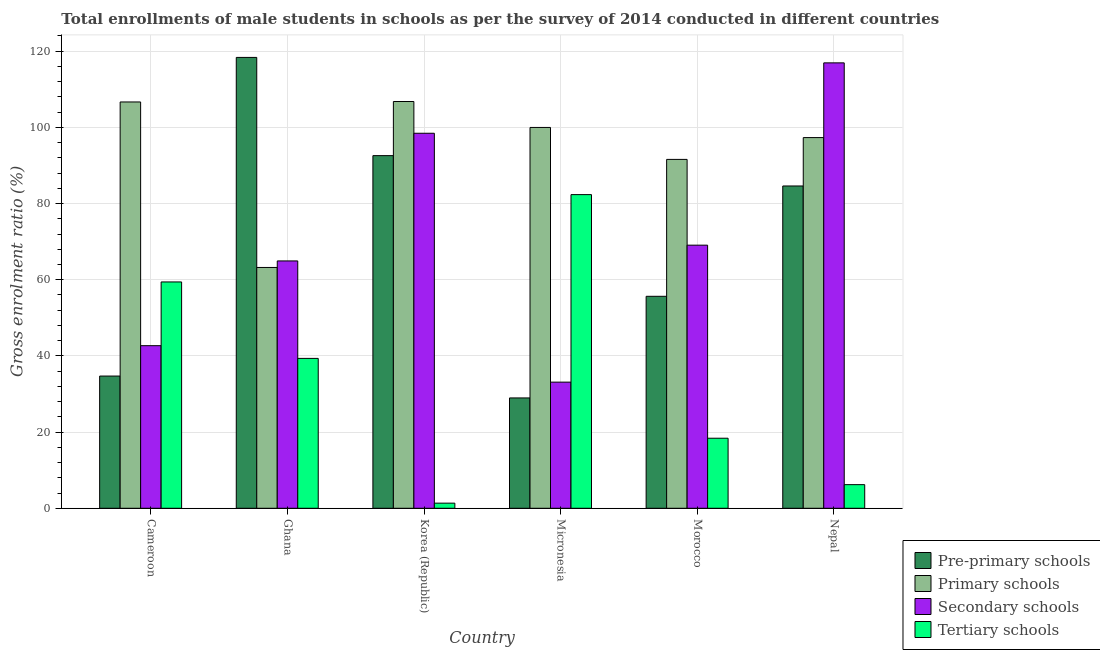How many different coloured bars are there?
Provide a short and direct response. 4. How many groups of bars are there?
Your answer should be compact. 6. How many bars are there on the 4th tick from the left?
Provide a short and direct response. 4. What is the label of the 5th group of bars from the left?
Keep it short and to the point. Morocco. What is the gross enrolment ratio(male) in secondary schools in Korea (Republic)?
Offer a terse response. 98.45. Across all countries, what is the maximum gross enrolment ratio(male) in tertiary schools?
Provide a succinct answer. 82.35. Across all countries, what is the minimum gross enrolment ratio(male) in secondary schools?
Your response must be concise. 33.12. In which country was the gross enrolment ratio(male) in secondary schools maximum?
Ensure brevity in your answer.  Nepal. What is the total gross enrolment ratio(male) in tertiary schools in the graph?
Offer a terse response. 207.05. What is the difference between the gross enrolment ratio(male) in secondary schools in Ghana and that in Morocco?
Provide a succinct answer. -4.14. What is the difference between the gross enrolment ratio(male) in primary schools in Korea (Republic) and the gross enrolment ratio(male) in pre-primary schools in Morocco?
Give a very brief answer. 51.14. What is the average gross enrolment ratio(male) in pre-primary schools per country?
Provide a succinct answer. 69.15. What is the difference between the gross enrolment ratio(male) in secondary schools and gross enrolment ratio(male) in tertiary schools in Korea (Republic)?
Offer a very short reply. 97.11. In how many countries, is the gross enrolment ratio(male) in tertiary schools greater than 24 %?
Give a very brief answer. 3. What is the ratio of the gross enrolment ratio(male) in pre-primary schools in Korea (Republic) to that in Nepal?
Your answer should be compact. 1.09. Is the gross enrolment ratio(male) in pre-primary schools in Ghana less than that in Morocco?
Make the answer very short. No. Is the difference between the gross enrolment ratio(male) in tertiary schools in Cameroon and Morocco greater than the difference between the gross enrolment ratio(male) in pre-primary schools in Cameroon and Morocco?
Offer a very short reply. Yes. What is the difference between the highest and the second highest gross enrolment ratio(male) in pre-primary schools?
Keep it short and to the point. 25.78. What is the difference between the highest and the lowest gross enrolment ratio(male) in secondary schools?
Offer a terse response. 83.82. Is the sum of the gross enrolment ratio(male) in pre-primary schools in Korea (Republic) and Nepal greater than the maximum gross enrolment ratio(male) in tertiary schools across all countries?
Give a very brief answer. Yes. What does the 3rd bar from the left in Morocco represents?
Keep it short and to the point. Secondary schools. What does the 4th bar from the right in Nepal represents?
Provide a succinct answer. Pre-primary schools. Are all the bars in the graph horizontal?
Your response must be concise. No. Are the values on the major ticks of Y-axis written in scientific E-notation?
Give a very brief answer. No. Does the graph contain any zero values?
Offer a terse response. No. How many legend labels are there?
Ensure brevity in your answer.  4. What is the title of the graph?
Your response must be concise. Total enrollments of male students in schools as per the survey of 2014 conducted in different countries. What is the label or title of the X-axis?
Your response must be concise. Country. What is the label or title of the Y-axis?
Keep it short and to the point. Gross enrolment ratio (%). What is the Gross enrolment ratio (%) in Pre-primary schools in Cameroon?
Give a very brief answer. 34.71. What is the Gross enrolment ratio (%) of Primary schools in Cameroon?
Make the answer very short. 106.67. What is the Gross enrolment ratio (%) of Secondary schools in Cameroon?
Provide a short and direct response. 42.69. What is the Gross enrolment ratio (%) in Tertiary schools in Cameroon?
Offer a terse response. 59.42. What is the Gross enrolment ratio (%) of Pre-primary schools in Ghana?
Offer a very short reply. 118.37. What is the Gross enrolment ratio (%) of Primary schools in Ghana?
Your answer should be very brief. 63.22. What is the Gross enrolment ratio (%) in Secondary schools in Ghana?
Your answer should be compact. 64.94. What is the Gross enrolment ratio (%) of Tertiary schools in Ghana?
Provide a succinct answer. 39.35. What is the Gross enrolment ratio (%) of Pre-primary schools in Korea (Republic)?
Your response must be concise. 92.58. What is the Gross enrolment ratio (%) of Primary schools in Korea (Republic)?
Provide a short and direct response. 106.79. What is the Gross enrolment ratio (%) of Secondary schools in Korea (Republic)?
Keep it short and to the point. 98.45. What is the Gross enrolment ratio (%) in Tertiary schools in Korea (Republic)?
Your response must be concise. 1.35. What is the Gross enrolment ratio (%) of Pre-primary schools in Micronesia?
Make the answer very short. 28.97. What is the Gross enrolment ratio (%) in Primary schools in Micronesia?
Ensure brevity in your answer.  99.98. What is the Gross enrolment ratio (%) in Secondary schools in Micronesia?
Give a very brief answer. 33.12. What is the Gross enrolment ratio (%) in Tertiary schools in Micronesia?
Offer a terse response. 82.35. What is the Gross enrolment ratio (%) of Pre-primary schools in Morocco?
Provide a short and direct response. 55.65. What is the Gross enrolment ratio (%) of Primary schools in Morocco?
Your response must be concise. 91.59. What is the Gross enrolment ratio (%) in Secondary schools in Morocco?
Offer a very short reply. 69.08. What is the Gross enrolment ratio (%) of Tertiary schools in Morocco?
Offer a very short reply. 18.39. What is the Gross enrolment ratio (%) in Pre-primary schools in Nepal?
Your response must be concise. 84.62. What is the Gross enrolment ratio (%) in Primary schools in Nepal?
Provide a succinct answer. 97.32. What is the Gross enrolment ratio (%) of Secondary schools in Nepal?
Your response must be concise. 116.94. What is the Gross enrolment ratio (%) in Tertiary schools in Nepal?
Offer a very short reply. 6.2. Across all countries, what is the maximum Gross enrolment ratio (%) in Pre-primary schools?
Offer a very short reply. 118.37. Across all countries, what is the maximum Gross enrolment ratio (%) of Primary schools?
Your answer should be compact. 106.79. Across all countries, what is the maximum Gross enrolment ratio (%) in Secondary schools?
Make the answer very short. 116.94. Across all countries, what is the maximum Gross enrolment ratio (%) in Tertiary schools?
Provide a short and direct response. 82.35. Across all countries, what is the minimum Gross enrolment ratio (%) in Pre-primary schools?
Your response must be concise. 28.97. Across all countries, what is the minimum Gross enrolment ratio (%) of Primary schools?
Give a very brief answer. 63.22. Across all countries, what is the minimum Gross enrolment ratio (%) in Secondary schools?
Provide a succinct answer. 33.12. Across all countries, what is the minimum Gross enrolment ratio (%) of Tertiary schools?
Give a very brief answer. 1.35. What is the total Gross enrolment ratio (%) of Pre-primary schools in the graph?
Provide a succinct answer. 414.89. What is the total Gross enrolment ratio (%) in Primary schools in the graph?
Your answer should be very brief. 565.57. What is the total Gross enrolment ratio (%) of Secondary schools in the graph?
Keep it short and to the point. 425.21. What is the total Gross enrolment ratio (%) of Tertiary schools in the graph?
Give a very brief answer. 207.05. What is the difference between the Gross enrolment ratio (%) in Pre-primary schools in Cameroon and that in Ghana?
Your response must be concise. -83.65. What is the difference between the Gross enrolment ratio (%) in Primary schools in Cameroon and that in Ghana?
Your response must be concise. 43.45. What is the difference between the Gross enrolment ratio (%) of Secondary schools in Cameroon and that in Ghana?
Offer a terse response. -22.25. What is the difference between the Gross enrolment ratio (%) in Tertiary schools in Cameroon and that in Ghana?
Ensure brevity in your answer.  20.07. What is the difference between the Gross enrolment ratio (%) in Pre-primary schools in Cameroon and that in Korea (Republic)?
Give a very brief answer. -57.87. What is the difference between the Gross enrolment ratio (%) of Primary schools in Cameroon and that in Korea (Republic)?
Offer a terse response. -0.12. What is the difference between the Gross enrolment ratio (%) of Secondary schools in Cameroon and that in Korea (Republic)?
Offer a terse response. -55.77. What is the difference between the Gross enrolment ratio (%) in Tertiary schools in Cameroon and that in Korea (Republic)?
Ensure brevity in your answer.  58.07. What is the difference between the Gross enrolment ratio (%) of Pre-primary schools in Cameroon and that in Micronesia?
Your answer should be compact. 5.74. What is the difference between the Gross enrolment ratio (%) of Primary schools in Cameroon and that in Micronesia?
Your response must be concise. 6.69. What is the difference between the Gross enrolment ratio (%) in Secondary schools in Cameroon and that in Micronesia?
Provide a succinct answer. 9.57. What is the difference between the Gross enrolment ratio (%) in Tertiary schools in Cameroon and that in Micronesia?
Keep it short and to the point. -22.93. What is the difference between the Gross enrolment ratio (%) in Pre-primary schools in Cameroon and that in Morocco?
Give a very brief answer. -20.94. What is the difference between the Gross enrolment ratio (%) of Primary schools in Cameroon and that in Morocco?
Give a very brief answer. 15.08. What is the difference between the Gross enrolment ratio (%) of Secondary schools in Cameroon and that in Morocco?
Keep it short and to the point. -26.39. What is the difference between the Gross enrolment ratio (%) of Tertiary schools in Cameroon and that in Morocco?
Provide a short and direct response. 41.03. What is the difference between the Gross enrolment ratio (%) in Pre-primary schools in Cameroon and that in Nepal?
Provide a short and direct response. -49.9. What is the difference between the Gross enrolment ratio (%) in Primary schools in Cameroon and that in Nepal?
Ensure brevity in your answer.  9.35. What is the difference between the Gross enrolment ratio (%) in Secondary schools in Cameroon and that in Nepal?
Provide a succinct answer. -74.25. What is the difference between the Gross enrolment ratio (%) of Tertiary schools in Cameroon and that in Nepal?
Ensure brevity in your answer.  53.21. What is the difference between the Gross enrolment ratio (%) in Pre-primary schools in Ghana and that in Korea (Republic)?
Give a very brief answer. 25.78. What is the difference between the Gross enrolment ratio (%) in Primary schools in Ghana and that in Korea (Republic)?
Offer a terse response. -43.57. What is the difference between the Gross enrolment ratio (%) of Secondary schools in Ghana and that in Korea (Republic)?
Provide a short and direct response. -33.52. What is the difference between the Gross enrolment ratio (%) of Tertiary schools in Ghana and that in Korea (Republic)?
Provide a succinct answer. 38. What is the difference between the Gross enrolment ratio (%) of Pre-primary schools in Ghana and that in Micronesia?
Offer a terse response. 89.4. What is the difference between the Gross enrolment ratio (%) in Primary schools in Ghana and that in Micronesia?
Provide a succinct answer. -36.76. What is the difference between the Gross enrolment ratio (%) of Secondary schools in Ghana and that in Micronesia?
Ensure brevity in your answer.  31.82. What is the difference between the Gross enrolment ratio (%) in Tertiary schools in Ghana and that in Micronesia?
Offer a very short reply. -43. What is the difference between the Gross enrolment ratio (%) in Pre-primary schools in Ghana and that in Morocco?
Keep it short and to the point. 62.72. What is the difference between the Gross enrolment ratio (%) in Primary schools in Ghana and that in Morocco?
Offer a terse response. -28.37. What is the difference between the Gross enrolment ratio (%) in Secondary schools in Ghana and that in Morocco?
Provide a short and direct response. -4.14. What is the difference between the Gross enrolment ratio (%) of Tertiary schools in Ghana and that in Morocco?
Your answer should be very brief. 20.96. What is the difference between the Gross enrolment ratio (%) of Pre-primary schools in Ghana and that in Nepal?
Make the answer very short. 33.75. What is the difference between the Gross enrolment ratio (%) of Primary schools in Ghana and that in Nepal?
Ensure brevity in your answer.  -34.1. What is the difference between the Gross enrolment ratio (%) in Secondary schools in Ghana and that in Nepal?
Make the answer very short. -52. What is the difference between the Gross enrolment ratio (%) of Tertiary schools in Ghana and that in Nepal?
Provide a succinct answer. 33.14. What is the difference between the Gross enrolment ratio (%) of Pre-primary schools in Korea (Republic) and that in Micronesia?
Provide a succinct answer. 63.61. What is the difference between the Gross enrolment ratio (%) in Primary schools in Korea (Republic) and that in Micronesia?
Provide a succinct answer. 6.81. What is the difference between the Gross enrolment ratio (%) in Secondary schools in Korea (Republic) and that in Micronesia?
Ensure brevity in your answer.  65.34. What is the difference between the Gross enrolment ratio (%) of Tertiary schools in Korea (Republic) and that in Micronesia?
Your response must be concise. -81. What is the difference between the Gross enrolment ratio (%) of Pre-primary schools in Korea (Republic) and that in Morocco?
Make the answer very short. 36.93. What is the difference between the Gross enrolment ratio (%) in Primary schools in Korea (Republic) and that in Morocco?
Your answer should be very brief. 15.2. What is the difference between the Gross enrolment ratio (%) of Secondary schools in Korea (Republic) and that in Morocco?
Provide a succinct answer. 29.38. What is the difference between the Gross enrolment ratio (%) of Tertiary schools in Korea (Republic) and that in Morocco?
Your answer should be compact. -17.04. What is the difference between the Gross enrolment ratio (%) in Pre-primary schools in Korea (Republic) and that in Nepal?
Offer a very short reply. 7.97. What is the difference between the Gross enrolment ratio (%) in Primary schools in Korea (Republic) and that in Nepal?
Your answer should be very brief. 9.47. What is the difference between the Gross enrolment ratio (%) in Secondary schools in Korea (Republic) and that in Nepal?
Provide a succinct answer. -18.48. What is the difference between the Gross enrolment ratio (%) in Tertiary schools in Korea (Republic) and that in Nepal?
Ensure brevity in your answer.  -4.86. What is the difference between the Gross enrolment ratio (%) in Pre-primary schools in Micronesia and that in Morocco?
Your answer should be very brief. -26.68. What is the difference between the Gross enrolment ratio (%) in Primary schools in Micronesia and that in Morocco?
Make the answer very short. 8.39. What is the difference between the Gross enrolment ratio (%) of Secondary schools in Micronesia and that in Morocco?
Offer a terse response. -35.96. What is the difference between the Gross enrolment ratio (%) of Tertiary schools in Micronesia and that in Morocco?
Ensure brevity in your answer.  63.96. What is the difference between the Gross enrolment ratio (%) in Pre-primary schools in Micronesia and that in Nepal?
Provide a succinct answer. -55.65. What is the difference between the Gross enrolment ratio (%) of Primary schools in Micronesia and that in Nepal?
Offer a terse response. 2.66. What is the difference between the Gross enrolment ratio (%) of Secondary schools in Micronesia and that in Nepal?
Provide a short and direct response. -83.82. What is the difference between the Gross enrolment ratio (%) of Tertiary schools in Micronesia and that in Nepal?
Ensure brevity in your answer.  76.14. What is the difference between the Gross enrolment ratio (%) in Pre-primary schools in Morocco and that in Nepal?
Offer a terse response. -28.96. What is the difference between the Gross enrolment ratio (%) in Primary schools in Morocco and that in Nepal?
Offer a very short reply. -5.73. What is the difference between the Gross enrolment ratio (%) in Secondary schools in Morocco and that in Nepal?
Provide a short and direct response. -47.86. What is the difference between the Gross enrolment ratio (%) in Tertiary schools in Morocco and that in Nepal?
Ensure brevity in your answer.  12.19. What is the difference between the Gross enrolment ratio (%) in Pre-primary schools in Cameroon and the Gross enrolment ratio (%) in Primary schools in Ghana?
Make the answer very short. -28.51. What is the difference between the Gross enrolment ratio (%) of Pre-primary schools in Cameroon and the Gross enrolment ratio (%) of Secondary schools in Ghana?
Provide a succinct answer. -30.22. What is the difference between the Gross enrolment ratio (%) of Pre-primary schools in Cameroon and the Gross enrolment ratio (%) of Tertiary schools in Ghana?
Make the answer very short. -4.63. What is the difference between the Gross enrolment ratio (%) in Primary schools in Cameroon and the Gross enrolment ratio (%) in Secondary schools in Ghana?
Offer a terse response. 41.73. What is the difference between the Gross enrolment ratio (%) of Primary schools in Cameroon and the Gross enrolment ratio (%) of Tertiary schools in Ghana?
Your answer should be very brief. 67.32. What is the difference between the Gross enrolment ratio (%) in Secondary schools in Cameroon and the Gross enrolment ratio (%) in Tertiary schools in Ghana?
Offer a terse response. 3.34. What is the difference between the Gross enrolment ratio (%) in Pre-primary schools in Cameroon and the Gross enrolment ratio (%) in Primary schools in Korea (Republic)?
Keep it short and to the point. -72.08. What is the difference between the Gross enrolment ratio (%) in Pre-primary schools in Cameroon and the Gross enrolment ratio (%) in Secondary schools in Korea (Republic)?
Give a very brief answer. -63.74. What is the difference between the Gross enrolment ratio (%) of Pre-primary schools in Cameroon and the Gross enrolment ratio (%) of Tertiary schools in Korea (Republic)?
Ensure brevity in your answer.  33.37. What is the difference between the Gross enrolment ratio (%) in Primary schools in Cameroon and the Gross enrolment ratio (%) in Secondary schools in Korea (Republic)?
Offer a terse response. 8.22. What is the difference between the Gross enrolment ratio (%) in Primary schools in Cameroon and the Gross enrolment ratio (%) in Tertiary schools in Korea (Republic)?
Your answer should be compact. 105.32. What is the difference between the Gross enrolment ratio (%) in Secondary schools in Cameroon and the Gross enrolment ratio (%) in Tertiary schools in Korea (Republic)?
Your answer should be very brief. 41.34. What is the difference between the Gross enrolment ratio (%) of Pre-primary schools in Cameroon and the Gross enrolment ratio (%) of Primary schools in Micronesia?
Offer a terse response. -65.27. What is the difference between the Gross enrolment ratio (%) in Pre-primary schools in Cameroon and the Gross enrolment ratio (%) in Secondary schools in Micronesia?
Offer a very short reply. 1.6. What is the difference between the Gross enrolment ratio (%) in Pre-primary schools in Cameroon and the Gross enrolment ratio (%) in Tertiary schools in Micronesia?
Provide a succinct answer. -47.63. What is the difference between the Gross enrolment ratio (%) of Primary schools in Cameroon and the Gross enrolment ratio (%) of Secondary schools in Micronesia?
Your response must be concise. 73.55. What is the difference between the Gross enrolment ratio (%) in Primary schools in Cameroon and the Gross enrolment ratio (%) in Tertiary schools in Micronesia?
Ensure brevity in your answer.  24.32. What is the difference between the Gross enrolment ratio (%) in Secondary schools in Cameroon and the Gross enrolment ratio (%) in Tertiary schools in Micronesia?
Provide a short and direct response. -39.66. What is the difference between the Gross enrolment ratio (%) of Pre-primary schools in Cameroon and the Gross enrolment ratio (%) of Primary schools in Morocco?
Offer a terse response. -56.88. What is the difference between the Gross enrolment ratio (%) of Pre-primary schools in Cameroon and the Gross enrolment ratio (%) of Secondary schools in Morocco?
Give a very brief answer. -34.36. What is the difference between the Gross enrolment ratio (%) in Pre-primary schools in Cameroon and the Gross enrolment ratio (%) in Tertiary schools in Morocco?
Your answer should be very brief. 16.32. What is the difference between the Gross enrolment ratio (%) of Primary schools in Cameroon and the Gross enrolment ratio (%) of Secondary schools in Morocco?
Offer a very short reply. 37.59. What is the difference between the Gross enrolment ratio (%) of Primary schools in Cameroon and the Gross enrolment ratio (%) of Tertiary schools in Morocco?
Give a very brief answer. 88.28. What is the difference between the Gross enrolment ratio (%) in Secondary schools in Cameroon and the Gross enrolment ratio (%) in Tertiary schools in Morocco?
Offer a very short reply. 24.3. What is the difference between the Gross enrolment ratio (%) of Pre-primary schools in Cameroon and the Gross enrolment ratio (%) of Primary schools in Nepal?
Provide a short and direct response. -62.61. What is the difference between the Gross enrolment ratio (%) in Pre-primary schools in Cameroon and the Gross enrolment ratio (%) in Secondary schools in Nepal?
Ensure brevity in your answer.  -82.22. What is the difference between the Gross enrolment ratio (%) in Pre-primary schools in Cameroon and the Gross enrolment ratio (%) in Tertiary schools in Nepal?
Offer a very short reply. 28.51. What is the difference between the Gross enrolment ratio (%) in Primary schools in Cameroon and the Gross enrolment ratio (%) in Secondary schools in Nepal?
Give a very brief answer. -10.27. What is the difference between the Gross enrolment ratio (%) of Primary schools in Cameroon and the Gross enrolment ratio (%) of Tertiary schools in Nepal?
Provide a succinct answer. 100.47. What is the difference between the Gross enrolment ratio (%) of Secondary schools in Cameroon and the Gross enrolment ratio (%) of Tertiary schools in Nepal?
Provide a short and direct response. 36.48. What is the difference between the Gross enrolment ratio (%) of Pre-primary schools in Ghana and the Gross enrolment ratio (%) of Primary schools in Korea (Republic)?
Keep it short and to the point. 11.58. What is the difference between the Gross enrolment ratio (%) of Pre-primary schools in Ghana and the Gross enrolment ratio (%) of Secondary schools in Korea (Republic)?
Your response must be concise. 19.91. What is the difference between the Gross enrolment ratio (%) in Pre-primary schools in Ghana and the Gross enrolment ratio (%) in Tertiary schools in Korea (Republic)?
Provide a succinct answer. 117.02. What is the difference between the Gross enrolment ratio (%) of Primary schools in Ghana and the Gross enrolment ratio (%) of Secondary schools in Korea (Republic)?
Make the answer very short. -35.23. What is the difference between the Gross enrolment ratio (%) of Primary schools in Ghana and the Gross enrolment ratio (%) of Tertiary schools in Korea (Republic)?
Give a very brief answer. 61.87. What is the difference between the Gross enrolment ratio (%) in Secondary schools in Ghana and the Gross enrolment ratio (%) in Tertiary schools in Korea (Republic)?
Ensure brevity in your answer.  63.59. What is the difference between the Gross enrolment ratio (%) of Pre-primary schools in Ghana and the Gross enrolment ratio (%) of Primary schools in Micronesia?
Provide a succinct answer. 18.39. What is the difference between the Gross enrolment ratio (%) in Pre-primary schools in Ghana and the Gross enrolment ratio (%) in Secondary schools in Micronesia?
Offer a terse response. 85.25. What is the difference between the Gross enrolment ratio (%) in Pre-primary schools in Ghana and the Gross enrolment ratio (%) in Tertiary schools in Micronesia?
Offer a terse response. 36.02. What is the difference between the Gross enrolment ratio (%) of Primary schools in Ghana and the Gross enrolment ratio (%) of Secondary schools in Micronesia?
Your response must be concise. 30.1. What is the difference between the Gross enrolment ratio (%) of Primary schools in Ghana and the Gross enrolment ratio (%) of Tertiary schools in Micronesia?
Ensure brevity in your answer.  -19.13. What is the difference between the Gross enrolment ratio (%) of Secondary schools in Ghana and the Gross enrolment ratio (%) of Tertiary schools in Micronesia?
Your answer should be very brief. -17.41. What is the difference between the Gross enrolment ratio (%) of Pre-primary schools in Ghana and the Gross enrolment ratio (%) of Primary schools in Morocco?
Keep it short and to the point. 26.77. What is the difference between the Gross enrolment ratio (%) of Pre-primary schools in Ghana and the Gross enrolment ratio (%) of Secondary schools in Morocco?
Provide a succinct answer. 49.29. What is the difference between the Gross enrolment ratio (%) of Pre-primary schools in Ghana and the Gross enrolment ratio (%) of Tertiary schools in Morocco?
Provide a succinct answer. 99.98. What is the difference between the Gross enrolment ratio (%) in Primary schools in Ghana and the Gross enrolment ratio (%) in Secondary schools in Morocco?
Provide a short and direct response. -5.86. What is the difference between the Gross enrolment ratio (%) in Primary schools in Ghana and the Gross enrolment ratio (%) in Tertiary schools in Morocco?
Give a very brief answer. 44.83. What is the difference between the Gross enrolment ratio (%) of Secondary schools in Ghana and the Gross enrolment ratio (%) of Tertiary schools in Morocco?
Your answer should be very brief. 46.55. What is the difference between the Gross enrolment ratio (%) in Pre-primary schools in Ghana and the Gross enrolment ratio (%) in Primary schools in Nepal?
Provide a succinct answer. 21.05. What is the difference between the Gross enrolment ratio (%) of Pre-primary schools in Ghana and the Gross enrolment ratio (%) of Secondary schools in Nepal?
Make the answer very short. 1.43. What is the difference between the Gross enrolment ratio (%) in Pre-primary schools in Ghana and the Gross enrolment ratio (%) in Tertiary schools in Nepal?
Offer a terse response. 112.16. What is the difference between the Gross enrolment ratio (%) in Primary schools in Ghana and the Gross enrolment ratio (%) in Secondary schools in Nepal?
Provide a short and direct response. -53.72. What is the difference between the Gross enrolment ratio (%) in Primary schools in Ghana and the Gross enrolment ratio (%) in Tertiary schools in Nepal?
Ensure brevity in your answer.  57.02. What is the difference between the Gross enrolment ratio (%) of Secondary schools in Ghana and the Gross enrolment ratio (%) of Tertiary schools in Nepal?
Ensure brevity in your answer.  58.73. What is the difference between the Gross enrolment ratio (%) in Pre-primary schools in Korea (Republic) and the Gross enrolment ratio (%) in Primary schools in Micronesia?
Your response must be concise. -7.4. What is the difference between the Gross enrolment ratio (%) of Pre-primary schools in Korea (Republic) and the Gross enrolment ratio (%) of Secondary schools in Micronesia?
Your answer should be compact. 59.46. What is the difference between the Gross enrolment ratio (%) in Pre-primary schools in Korea (Republic) and the Gross enrolment ratio (%) in Tertiary schools in Micronesia?
Provide a succinct answer. 10.23. What is the difference between the Gross enrolment ratio (%) in Primary schools in Korea (Republic) and the Gross enrolment ratio (%) in Secondary schools in Micronesia?
Provide a succinct answer. 73.67. What is the difference between the Gross enrolment ratio (%) of Primary schools in Korea (Republic) and the Gross enrolment ratio (%) of Tertiary schools in Micronesia?
Offer a terse response. 24.44. What is the difference between the Gross enrolment ratio (%) of Secondary schools in Korea (Republic) and the Gross enrolment ratio (%) of Tertiary schools in Micronesia?
Offer a terse response. 16.11. What is the difference between the Gross enrolment ratio (%) in Pre-primary schools in Korea (Republic) and the Gross enrolment ratio (%) in Primary schools in Morocco?
Provide a short and direct response. 0.99. What is the difference between the Gross enrolment ratio (%) of Pre-primary schools in Korea (Republic) and the Gross enrolment ratio (%) of Secondary schools in Morocco?
Offer a very short reply. 23.5. What is the difference between the Gross enrolment ratio (%) of Pre-primary schools in Korea (Republic) and the Gross enrolment ratio (%) of Tertiary schools in Morocco?
Offer a very short reply. 74.19. What is the difference between the Gross enrolment ratio (%) in Primary schools in Korea (Republic) and the Gross enrolment ratio (%) in Secondary schools in Morocco?
Keep it short and to the point. 37.71. What is the difference between the Gross enrolment ratio (%) of Primary schools in Korea (Republic) and the Gross enrolment ratio (%) of Tertiary schools in Morocco?
Your answer should be compact. 88.4. What is the difference between the Gross enrolment ratio (%) in Secondary schools in Korea (Republic) and the Gross enrolment ratio (%) in Tertiary schools in Morocco?
Give a very brief answer. 80.07. What is the difference between the Gross enrolment ratio (%) in Pre-primary schools in Korea (Republic) and the Gross enrolment ratio (%) in Primary schools in Nepal?
Your answer should be compact. -4.74. What is the difference between the Gross enrolment ratio (%) of Pre-primary schools in Korea (Republic) and the Gross enrolment ratio (%) of Secondary schools in Nepal?
Your response must be concise. -24.36. What is the difference between the Gross enrolment ratio (%) in Pre-primary schools in Korea (Republic) and the Gross enrolment ratio (%) in Tertiary schools in Nepal?
Your response must be concise. 86.38. What is the difference between the Gross enrolment ratio (%) in Primary schools in Korea (Republic) and the Gross enrolment ratio (%) in Secondary schools in Nepal?
Your answer should be compact. -10.15. What is the difference between the Gross enrolment ratio (%) in Primary schools in Korea (Republic) and the Gross enrolment ratio (%) in Tertiary schools in Nepal?
Your response must be concise. 100.59. What is the difference between the Gross enrolment ratio (%) in Secondary schools in Korea (Republic) and the Gross enrolment ratio (%) in Tertiary schools in Nepal?
Your answer should be very brief. 92.25. What is the difference between the Gross enrolment ratio (%) in Pre-primary schools in Micronesia and the Gross enrolment ratio (%) in Primary schools in Morocco?
Provide a short and direct response. -62.62. What is the difference between the Gross enrolment ratio (%) of Pre-primary schools in Micronesia and the Gross enrolment ratio (%) of Secondary schools in Morocco?
Your answer should be compact. -40.11. What is the difference between the Gross enrolment ratio (%) in Pre-primary schools in Micronesia and the Gross enrolment ratio (%) in Tertiary schools in Morocco?
Provide a succinct answer. 10.58. What is the difference between the Gross enrolment ratio (%) in Primary schools in Micronesia and the Gross enrolment ratio (%) in Secondary schools in Morocco?
Provide a succinct answer. 30.9. What is the difference between the Gross enrolment ratio (%) of Primary schools in Micronesia and the Gross enrolment ratio (%) of Tertiary schools in Morocco?
Offer a very short reply. 81.59. What is the difference between the Gross enrolment ratio (%) in Secondary schools in Micronesia and the Gross enrolment ratio (%) in Tertiary schools in Morocco?
Offer a very short reply. 14.73. What is the difference between the Gross enrolment ratio (%) of Pre-primary schools in Micronesia and the Gross enrolment ratio (%) of Primary schools in Nepal?
Give a very brief answer. -68.35. What is the difference between the Gross enrolment ratio (%) of Pre-primary schools in Micronesia and the Gross enrolment ratio (%) of Secondary schools in Nepal?
Provide a short and direct response. -87.97. What is the difference between the Gross enrolment ratio (%) of Pre-primary schools in Micronesia and the Gross enrolment ratio (%) of Tertiary schools in Nepal?
Ensure brevity in your answer.  22.77. What is the difference between the Gross enrolment ratio (%) in Primary schools in Micronesia and the Gross enrolment ratio (%) in Secondary schools in Nepal?
Make the answer very short. -16.96. What is the difference between the Gross enrolment ratio (%) in Primary schools in Micronesia and the Gross enrolment ratio (%) in Tertiary schools in Nepal?
Make the answer very short. 93.78. What is the difference between the Gross enrolment ratio (%) in Secondary schools in Micronesia and the Gross enrolment ratio (%) in Tertiary schools in Nepal?
Your answer should be very brief. 26.91. What is the difference between the Gross enrolment ratio (%) of Pre-primary schools in Morocco and the Gross enrolment ratio (%) of Primary schools in Nepal?
Your response must be concise. -41.67. What is the difference between the Gross enrolment ratio (%) of Pre-primary schools in Morocco and the Gross enrolment ratio (%) of Secondary schools in Nepal?
Make the answer very short. -61.29. What is the difference between the Gross enrolment ratio (%) in Pre-primary schools in Morocco and the Gross enrolment ratio (%) in Tertiary schools in Nepal?
Offer a very short reply. 49.45. What is the difference between the Gross enrolment ratio (%) in Primary schools in Morocco and the Gross enrolment ratio (%) in Secondary schools in Nepal?
Give a very brief answer. -25.35. What is the difference between the Gross enrolment ratio (%) of Primary schools in Morocco and the Gross enrolment ratio (%) of Tertiary schools in Nepal?
Provide a short and direct response. 85.39. What is the difference between the Gross enrolment ratio (%) of Secondary schools in Morocco and the Gross enrolment ratio (%) of Tertiary schools in Nepal?
Offer a very short reply. 62.87. What is the average Gross enrolment ratio (%) in Pre-primary schools per country?
Provide a short and direct response. 69.15. What is the average Gross enrolment ratio (%) in Primary schools per country?
Keep it short and to the point. 94.26. What is the average Gross enrolment ratio (%) of Secondary schools per country?
Your answer should be very brief. 70.87. What is the average Gross enrolment ratio (%) in Tertiary schools per country?
Ensure brevity in your answer.  34.51. What is the difference between the Gross enrolment ratio (%) in Pre-primary schools and Gross enrolment ratio (%) in Primary schools in Cameroon?
Give a very brief answer. -71.96. What is the difference between the Gross enrolment ratio (%) of Pre-primary schools and Gross enrolment ratio (%) of Secondary schools in Cameroon?
Make the answer very short. -7.97. What is the difference between the Gross enrolment ratio (%) of Pre-primary schools and Gross enrolment ratio (%) of Tertiary schools in Cameroon?
Keep it short and to the point. -24.7. What is the difference between the Gross enrolment ratio (%) in Primary schools and Gross enrolment ratio (%) in Secondary schools in Cameroon?
Provide a succinct answer. 63.98. What is the difference between the Gross enrolment ratio (%) of Primary schools and Gross enrolment ratio (%) of Tertiary schools in Cameroon?
Offer a terse response. 47.25. What is the difference between the Gross enrolment ratio (%) of Secondary schools and Gross enrolment ratio (%) of Tertiary schools in Cameroon?
Give a very brief answer. -16.73. What is the difference between the Gross enrolment ratio (%) in Pre-primary schools and Gross enrolment ratio (%) in Primary schools in Ghana?
Offer a very short reply. 55.15. What is the difference between the Gross enrolment ratio (%) in Pre-primary schools and Gross enrolment ratio (%) in Secondary schools in Ghana?
Your answer should be compact. 53.43. What is the difference between the Gross enrolment ratio (%) in Pre-primary schools and Gross enrolment ratio (%) in Tertiary schools in Ghana?
Your answer should be compact. 79.02. What is the difference between the Gross enrolment ratio (%) of Primary schools and Gross enrolment ratio (%) of Secondary schools in Ghana?
Offer a very short reply. -1.72. What is the difference between the Gross enrolment ratio (%) of Primary schools and Gross enrolment ratio (%) of Tertiary schools in Ghana?
Keep it short and to the point. 23.87. What is the difference between the Gross enrolment ratio (%) of Secondary schools and Gross enrolment ratio (%) of Tertiary schools in Ghana?
Offer a terse response. 25.59. What is the difference between the Gross enrolment ratio (%) of Pre-primary schools and Gross enrolment ratio (%) of Primary schools in Korea (Republic)?
Provide a succinct answer. -14.21. What is the difference between the Gross enrolment ratio (%) in Pre-primary schools and Gross enrolment ratio (%) in Secondary schools in Korea (Republic)?
Offer a very short reply. -5.87. What is the difference between the Gross enrolment ratio (%) of Pre-primary schools and Gross enrolment ratio (%) of Tertiary schools in Korea (Republic)?
Ensure brevity in your answer.  91.23. What is the difference between the Gross enrolment ratio (%) in Primary schools and Gross enrolment ratio (%) in Secondary schools in Korea (Republic)?
Keep it short and to the point. 8.34. What is the difference between the Gross enrolment ratio (%) of Primary schools and Gross enrolment ratio (%) of Tertiary schools in Korea (Republic)?
Offer a terse response. 105.44. What is the difference between the Gross enrolment ratio (%) of Secondary schools and Gross enrolment ratio (%) of Tertiary schools in Korea (Republic)?
Your answer should be very brief. 97.11. What is the difference between the Gross enrolment ratio (%) in Pre-primary schools and Gross enrolment ratio (%) in Primary schools in Micronesia?
Give a very brief answer. -71.01. What is the difference between the Gross enrolment ratio (%) of Pre-primary schools and Gross enrolment ratio (%) of Secondary schools in Micronesia?
Offer a very short reply. -4.15. What is the difference between the Gross enrolment ratio (%) in Pre-primary schools and Gross enrolment ratio (%) in Tertiary schools in Micronesia?
Your answer should be compact. -53.38. What is the difference between the Gross enrolment ratio (%) in Primary schools and Gross enrolment ratio (%) in Secondary schools in Micronesia?
Your answer should be very brief. 66.86. What is the difference between the Gross enrolment ratio (%) of Primary schools and Gross enrolment ratio (%) of Tertiary schools in Micronesia?
Give a very brief answer. 17.63. What is the difference between the Gross enrolment ratio (%) of Secondary schools and Gross enrolment ratio (%) of Tertiary schools in Micronesia?
Make the answer very short. -49.23. What is the difference between the Gross enrolment ratio (%) of Pre-primary schools and Gross enrolment ratio (%) of Primary schools in Morocco?
Your response must be concise. -35.94. What is the difference between the Gross enrolment ratio (%) in Pre-primary schools and Gross enrolment ratio (%) in Secondary schools in Morocco?
Provide a succinct answer. -13.43. What is the difference between the Gross enrolment ratio (%) in Pre-primary schools and Gross enrolment ratio (%) in Tertiary schools in Morocco?
Offer a terse response. 37.26. What is the difference between the Gross enrolment ratio (%) in Primary schools and Gross enrolment ratio (%) in Secondary schools in Morocco?
Give a very brief answer. 22.51. What is the difference between the Gross enrolment ratio (%) in Primary schools and Gross enrolment ratio (%) in Tertiary schools in Morocco?
Provide a succinct answer. 73.2. What is the difference between the Gross enrolment ratio (%) of Secondary schools and Gross enrolment ratio (%) of Tertiary schools in Morocco?
Offer a very short reply. 50.69. What is the difference between the Gross enrolment ratio (%) of Pre-primary schools and Gross enrolment ratio (%) of Primary schools in Nepal?
Keep it short and to the point. -12.7. What is the difference between the Gross enrolment ratio (%) of Pre-primary schools and Gross enrolment ratio (%) of Secondary schools in Nepal?
Keep it short and to the point. -32.32. What is the difference between the Gross enrolment ratio (%) in Pre-primary schools and Gross enrolment ratio (%) in Tertiary schools in Nepal?
Make the answer very short. 78.41. What is the difference between the Gross enrolment ratio (%) of Primary schools and Gross enrolment ratio (%) of Secondary schools in Nepal?
Keep it short and to the point. -19.62. What is the difference between the Gross enrolment ratio (%) of Primary schools and Gross enrolment ratio (%) of Tertiary schools in Nepal?
Ensure brevity in your answer.  91.12. What is the difference between the Gross enrolment ratio (%) in Secondary schools and Gross enrolment ratio (%) in Tertiary schools in Nepal?
Make the answer very short. 110.73. What is the ratio of the Gross enrolment ratio (%) of Pre-primary schools in Cameroon to that in Ghana?
Provide a succinct answer. 0.29. What is the ratio of the Gross enrolment ratio (%) in Primary schools in Cameroon to that in Ghana?
Provide a short and direct response. 1.69. What is the ratio of the Gross enrolment ratio (%) in Secondary schools in Cameroon to that in Ghana?
Give a very brief answer. 0.66. What is the ratio of the Gross enrolment ratio (%) of Tertiary schools in Cameroon to that in Ghana?
Keep it short and to the point. 1.51. What is the ratio of the Gross enrolment ratio (%) in Pre-primary schools in Cameroon to that in Korea (Republic)?
Make the answer very short. 0.37. What is the ratio of the Gross enrolment ratio (%) in Secondary schools in Cameroon to that in Korea (Republic)?
Keep it short and to the point. 0.43. What is the ratio of the Gross enrolment ratio (%) in Tertiary schools in Cameroon to that in Korea (Republic)?
Your answer should be compact. 44.13. What is the ratio of the Gross enrolment ratio (%) of Pre-primary schools in Cameroon to that in Micronesia?
Offer a very short reply. 1.2. What is the ratio of the Gross enrolment ratio (%) of Primary schools in Cameroon to that in Micronesia?
Make the answer very short. 1.07. What is the ratio of the Gross enrolment ratio (%) in Secondary schools in Cameroon to that in Micronesia?
Offer a terse response. 1.29. What is the ratio of the Gross enrolment ratio (%) in Tertiary schools in Cameroon to that in Micronesia?
Your response must be concise. 0.72. What is the ratio of the Gross enrolment ratio (%) in Pre-primary schools in Cameroon to that in Morocco?
Your answer should be very brief. 0.62. What is the ratio of the Gross enrolment ratio (%) in Primary schools in Cameroon to that in Morocco?
Keep it short and to the point. 1.16. What is the ratio of the Gross enrolment ratio (%) of Secondary schools in Cameroon to that in Morocco?
Your response must be concise. 0.62. What is the ratio of the Gross enrolment ratio (%) in Tertiary schools in Cameroon to that in Morocco?
Offer a terse response. 3.23. What is the ratio of the Gross enrolment ratio (%) in Pre-primary schools in Cameroon to that in Nepal?
Your answer should be very brief. 0.41. What is the ratio of the Gross enrolment ratio (%) in Primary schools in Cameroon to that in Nepal?
Offer a very short reply. 1.1. What is the ratio of the Gross enrolment ratio (%) of Secondary schools in Cameroon to that in Nepal?
Your answer should be compact. 0.36. What is the ratio of the Gross enrolment ratio (%) in Tertiary schools in Cameroon to that in Nepal?
Your response must be concise. 9.58. What is the ratio of the Gross enrolment ratio (%) in Pre-primary schools in Ghana to that in Korea (Republic)?
Provide a succinct answer. 1.28. What is the ratio of the Gross enrolment ratio (%) of Primary schools in Ghana to that in Korea (Republic)?
Make the answer very short. 0.59. What is the ratio of the Gross enrolment ratio (%) in Secondary schools in Ghana to that in Korea (Republic)?
Your response must be concise. 0.66. What is the ratio of the Gross enrolment ratio (%) in Tertiary schools in Ghana to that in Korea (Republic)?
Make the answer very short. 29.23. What is the ratio of the Gross enrolment ratio (%) in Pre-primary schools in Ghana to that in Micronesia?
Make the answer very short. 4.09. What is the ratio of the Gross enrolment ratio (%) of Primary schools in Ghana to that in Micronesia?
Your answer should be compact. 0.63. What is the ratio of the Gross enrolment ratio (%) in Secondary schools in Ghana to that in Micronesia?
Give a very brief answer. 1.96. What is the ratio of the Gross enrolment ratio (%) in Tertiary schools in Ghana to that in Micronesia?
Your answer should be very brief. 0.48. What is the ratio of the Gross enrolment ratio (%) in Pre-primary schools in Ghana to that in Morocco?
Your response must be concise. 2.13. What is the ratio of the Gross enrolment ratio (%) of Primary schools in Ghana to that in Morocco?
Offer a very short reply. 0.69. What is the ratio of the Gross enrolment ratio (%) of Secondary schools in Ghana to that in Morocco?
Give a very brief answer. 0.94. What is the ratio of the Gross enrolment ratio (%) in Tertiary schools in Ghana to that in Morocco?
Provide a succinct answer. 2.14. What is the ratio of the Gross enrolment ratio (%) of Pre-primary schools in Ghana to that in Nepal?
Your response must be concise. 1.4. What is the ratio of the Gross enrolment ratio (%) in Primary schools in Ghana to that in Nepal?
Give a very brief answer. 0.65. What is the ratio of the Gross enrolment ratio (%) of Secondary schools in Ghana to that in Nepal?
Your response must be concise. 0.56. What is the ratio of the Gross enrolment ratio (%) of Tertiary schools in Ghana to that in Nepal?
Offer a very short reply. 6.34. What is the ratio of the Gross enrolment ratio (%) in Pre-primary schools in Korea (Republic) to that in Micronesia?
Your answer should be compact. 3.2. What is the ratio of the Gross enrolment ratio (%) in Primary schools in Korea (Republic) to that in Micronesia?
Make the answer very short. 1.07. What is the ratio of the Gross enrolment ratio (%) in Secondary schools in Korea (Republic) to that in Micronesia?
Your response must be concise. 2.97. What is the ratio of the Gross enrolment ratio (%) in Tertiary schools in Korea (Republic) to that in Micronesia?
Your answer should be compact. 0.02. What is the ratio of the Gross enrolment ratio (%) of Pre-primary schools in Korea (Republic) to that in Morocco?
Offer a terse response. 1.66. What is the ratio of the Gross enrolment ratio (%) of Primary schools in Korea (Republic) to that in Morocco?
Provide a short and direct response. 1.17. What is the ratio of the Gross enrolment ratio (%) in Secondary schools in Korea (Republic) to that in Morocco?
Keep it short and to the point. 1.43. What is the ratio of the Gross enrolment ratio (%) of Tertiary schools in Korea (Republic) to that in Morocco?
Your answer should be compact. 0.07. What is the ratio of the Gross enrolment ratio (%) in Pre-primary schools in Korea (Republic) to that in Nepal?
Make the answer very short. 1.09. What is the ratio of the Gross enrolment ratio (%) of Primary schools in Korea (Republic) to that in Nepal?
Your answer should be very brief. 1.1. What is the ratio of the Gross enrolment ratio (%) of Secondary schools in Korea (Republic) to that in Nepal?
Provide a succinct answer. 0.84. What is the ratio of the Gross enrolment ratio (%) of Tertiary schools in Korea (Republic) to that in Nepal?
Offer a terse response. 0.22. What is the ratio of the Gross enrolment ratio (%) in Pre-primary schools in Micronesia to that in Morocco?
Offer a very short reply. 0.52. What is the ratio of the Gross enrolment ratio (%) in Primary schools in Micronesia to that in Morocco?
Ensure brevity in your answer.  1.09. What is the ratio of the Gross enrolment ratio (%) of Secondary schools in Micronesia to that in Morocco?
Provide a succinct answer. 0.48. What is the ratio of the Gross enrolment ratio (%) in Tertiary schools in Micronesia to that in Morocco?
Keep it short and to the point. 4.48. What is the ratio of the Gross enrolment ratio (%) in Pre-primary schools in Micronesia to that in Nepal?
Give a very brief answer. 0.34. What is the ratio of the Gross enrolment ratio (%) in Primary schools in Micronesia to that in Nepal?
Your answer should be very brief. 1.03. What is the ratio of the Gross enrolment ratio (%) of Secondary schools in Micronesia to that in Nepal?
Your answer should be compact. 0.28. What is the ratio of the Gross enrolment ratio (%) of Tertiary schools in Micronesia to that in Nepal?
Offer a terse response. 13.28. What is the ratio of the Gross enrolment ratio (%) of Pre-primary schools in Morocco to that in Nepal?
Provide a short and direct response. 0.66. What is the ratio of the Gross enrolment ratio (%) in Primary schools in Morocco to that in Nepal?
Make the answer very short. 0.94. What is the ratio of the Gross enrolment ratio (%) of Secondary schools in Morocco to that in Nepal?
Ensure brevity in your answer.  0.59. What is the ratio of the Gross enrolment ratio (%) in Tertiary schools in Morocco to that in Nepal?
Provide a succinct answer. 2.96. What is the difference between the highest and the second highest Gross enrolment ratio (%) of Pre-primary schools?
Your response must be concise. 25.78. What is the difference between the highest and the second highest Gross enrolment ratio (%) of Primary schools?
Offer a terse response. 0.12. What is the difference between the highest and the second highest Gross enrolment ratio (%) in Secondary schools?
Your answer should be very brief. 18.48. What is the difference between the highest and the second highest Gross enrolment ratio (%) in Tertiary schools?
Your response must be concise. 22.93. What is the difference between the highest and the lowest Gross enrolment ratio (%) of Pre-primary schools?
Make the answer very short. 89.4. What is the difference between the highest and the lowest Gross enrolment ratio (%) in Primary schools?
Provide a short and direct response. 43.57. What is the difference between the highest and the lowest Gross enrolment ratio (%) of Secondary schools?
Your answer should be very brief. 83.82. What is the difference between the highest and the lowest Gross enrolment ratio (%) of Tertiary schools?
Give a very brief answer. 81. 